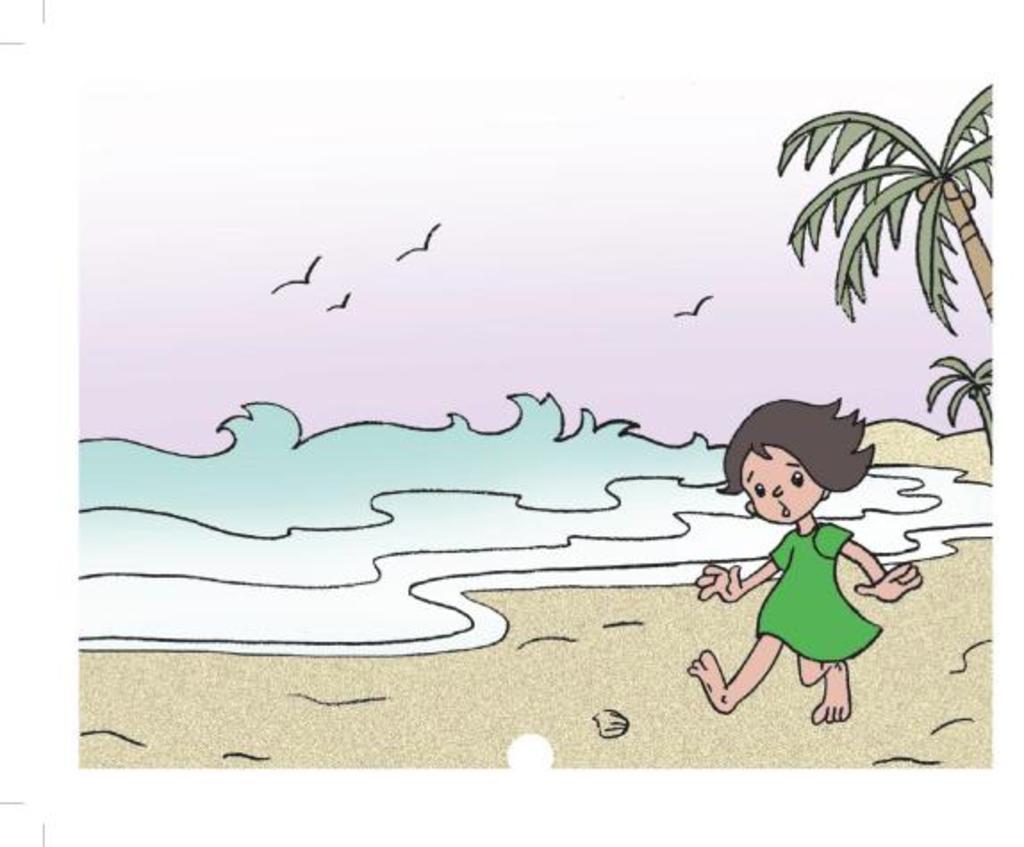Could you give a brief overview of what you see in this image? This is a drawing image of a cartoon girl on the beach side. 